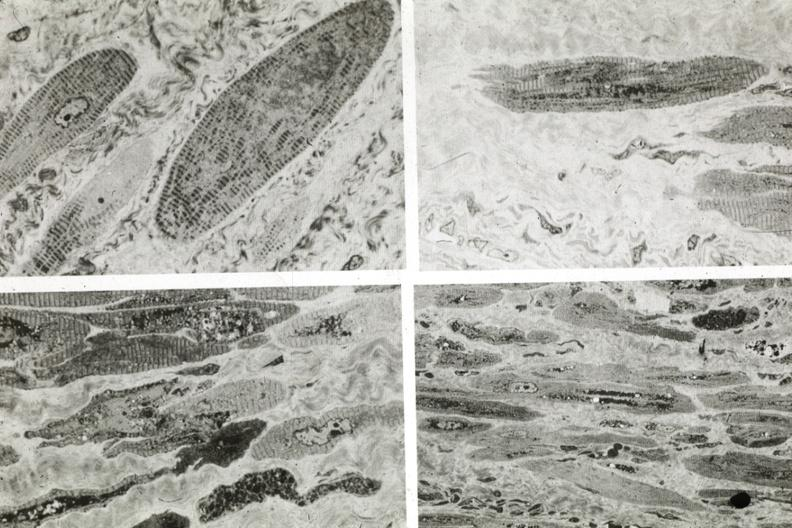where is this area in the body?
Answer the question using a single word or phrase. Heart 